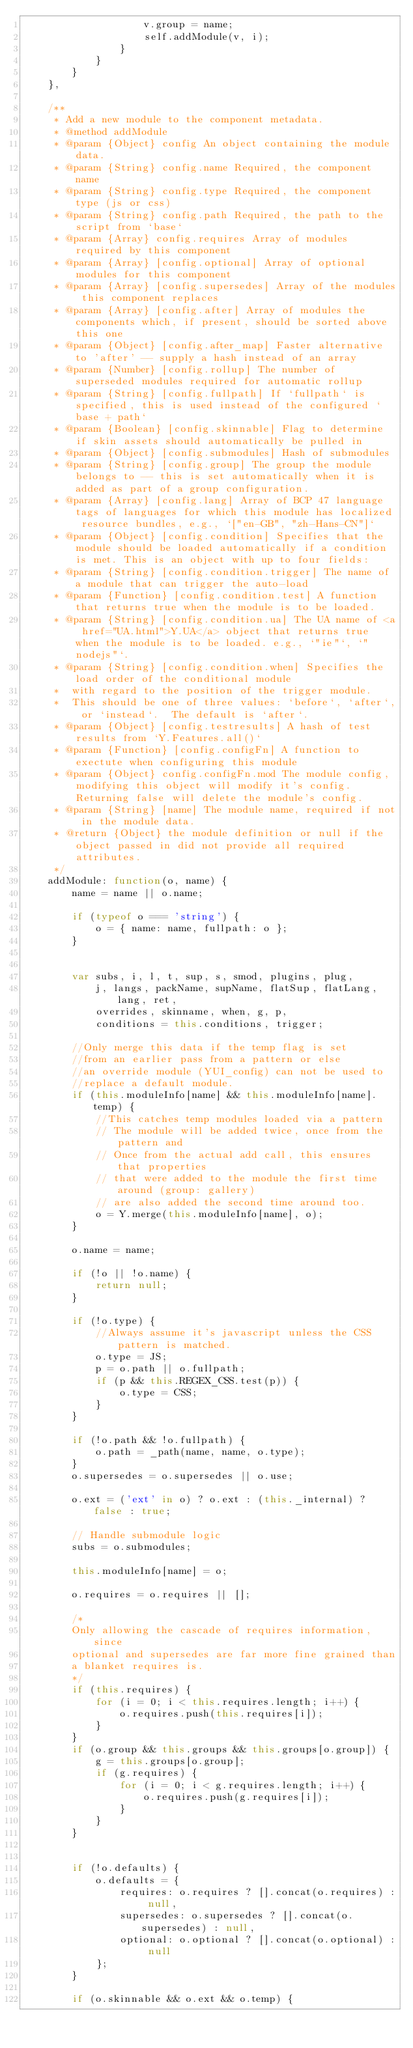Convert code to text. <code><loc_0><loc_0><loc_500><loc_500><_JavaScript_>                    v.group = name;
                    self.addModule(v, i);
                }
            }
        }
    },

    /**
     * Add a new module to the component metadata.
     * @method addModule
     * @param {Object} config An object containing the module data.
     * @param {String} config.name Required, the component name
     * @param {String} config.type Required, the component type (js or css)
     * @param {String} config.path Required, the path to the script from `base`
     * @param {Array} config.requires Array of modules required by this component
     * @param {Array} [config.optional] Array of optional modules for this component
     * @param {Array} [config.supersedes] Array of the modules this component replaces
     * @param {Array} [config.after] Array of modules the components which, if present, should be sorted above this one
     * @param {Object} [config.after_map] Faster alternative to 'after' -- supply a hash instead of an array
     * @param {Number} [config.rollup] The number of superseded modules required for automatic rollup
     * @param {String} [config.fullpath] If `fullpath` is specified, this is used instead of the configured `base + path`
     * @param {Boolean} [config.skinnable] Flag to determine if skin assets should automatically be pulled in
     * @param {Object} [config.submodules] Hash of submodules
     * @param {String} [config.group] The group the module belongs to -- this is set automatically when it is added as part of a group configuration.
     * @param {Array} [config.lang] Array of BCP 47 language tags of languages for which this module has localized resource bundles, e.g., `["en-GB", "zh-Hans-CN"]`
     * @param {Object} [config.condition] Specifies that the module should be loaded automatically if a condition is met. This is an object with up to four fields:
     * @param {String} [config.condition.trigger] The name of a module that can trigger the auto-load
     * @param {Function} [config.condition.test] A function that returns true when the module is to be loaded.
     * @param {String} [config.condition.ua] The UA name of <a href="UA.html">Y.UA</a> object that returns true when the module is to be loaded. e.g., `"ie"`, `"nodejs"`.
     * @param {String} [config.condition.when] Specifies the load order of the conditional module
     *  with regard to the position of the trigger module.
     *  This should be one of three values: `before`, `after`, or `instead`.  The default is `after`.
     * @param {Object} [config.testresults] A hash of test results from `Y.Features.all()`
     * @param {Function} [config.configFn] A function to exectute when configuring this module
     * @param {Object} config.configFn.mod The module config, modifying this object will modify it's config. Returning false will delete the module's config.
     * @param {String} [name] The module name, required if not in the module data.
     * @return {Object} the module definition or null if the object passed in did not provide all required attributes.
     */
    addModule: function(o, name) {
        name = name || o.name;

        if (typeof o === 'string') {
            o = { name: name, fullpath: o };
        }


        var subs, i, l, t, sup, s, smod, plugins, plug,
            j, langs, packName, supName, flatSup, flatLang, lang, ret,
            overrides, skinname, when, g, p,
            conditions = this.conditions, trigger;

        //Only merge this data if the temp flag is set
        //from an earlier pass from a pattern or else
        //an override module (YUI_config) can not be used to
        //replace a default module.
        if (this.moduleInfo[name] && this.moduleInfo[name].temp) {
            //This catches temp modules loaded via a pattern
            // The module will be added twice, once from the pattern and
            // Once from the actual add call, this ensures that properties
            // that were added to the module the first time around (group: gallery)
            // are also added the second time around too.
            o = Y.merge(this.moduleInfo[name], o);
        }

        o.name = name;

        if (!o || !o.name) {
            return null;
        }

        if (!o.type) {
            //Always assume it's javascript unless the CSS pattern is matched.
            o.type = JS;
            p = o.path || o.fullpath;
            if (p && this.REGEX_CSS.test(p)) {
                o.type = CSS;
            }
        }

        if (!o.path && !o.fullpath) {
            o.path = _path(name, name, o.type);
        }
        o.supersedes = o.supersedes || o.use;

        o.ext = ('ext' in o) ? o.ext : (this._internal) ? false : true;

        // Handle submodule logic
        subs = o.submodules;

        this.moduleInfo[name] = o;

        o.requires = o.requires || [];

        /*
        Only allowing the cascade of requires information, since
        optional and supersedes are far more fine grained than
        a blanket requires is.
        */
        if (this.requires) {
            for (i = 0; i < this.requires.length; i++) {
                o.requires.push(this.requires[i]);
            }
        }
        if (o.group && this.groups && this.groups[o.group]) {
            g = this.groups[o.group];
            if (g.requires) {
                for (i = 0; i < g.requires.length; i++) {
                    o.requires.push(g.requires[i]);
                }
            }
        }


        if (!o.defaults) {
            o.defaults = {
                requires: o.requires ? [].concat(o.requires) : null,
                supersedes: o.supersedes ? [].concat(o.supersedes) : null,
                optional: o.optional ? [].concat(o.optional) : null
            };
        }

        if (o.skinnable && o.ext && o.temp) {</code> 